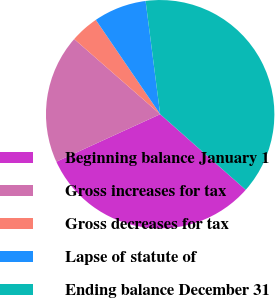<chart> <loc_0><loc_0><loc_500><loc_500><pie_chart><fcel>Beginning balance January 1<fcel>Gross increases for tax<fcel>Gross decreases for tax<fcel>Lapse of statute of<fcel>Ending balance December 31<nl><fcel>31.65%<fcel>18.26%<fcel>4.04%<fcel>7.49%<fcel>38.56%<nl></chart> 